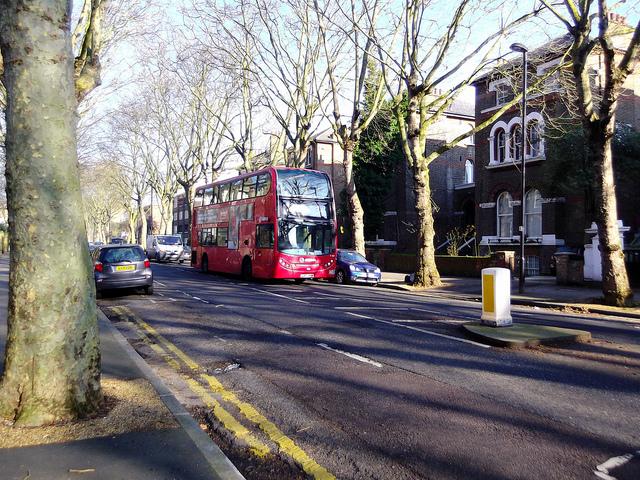Is the bus stopped?
Be succinct. Yes. What color is the bus?
Short answer required. Red. What season of the year is it?
Keep it brief. Fall. Is it a one way street?
Concise answer only. No. 